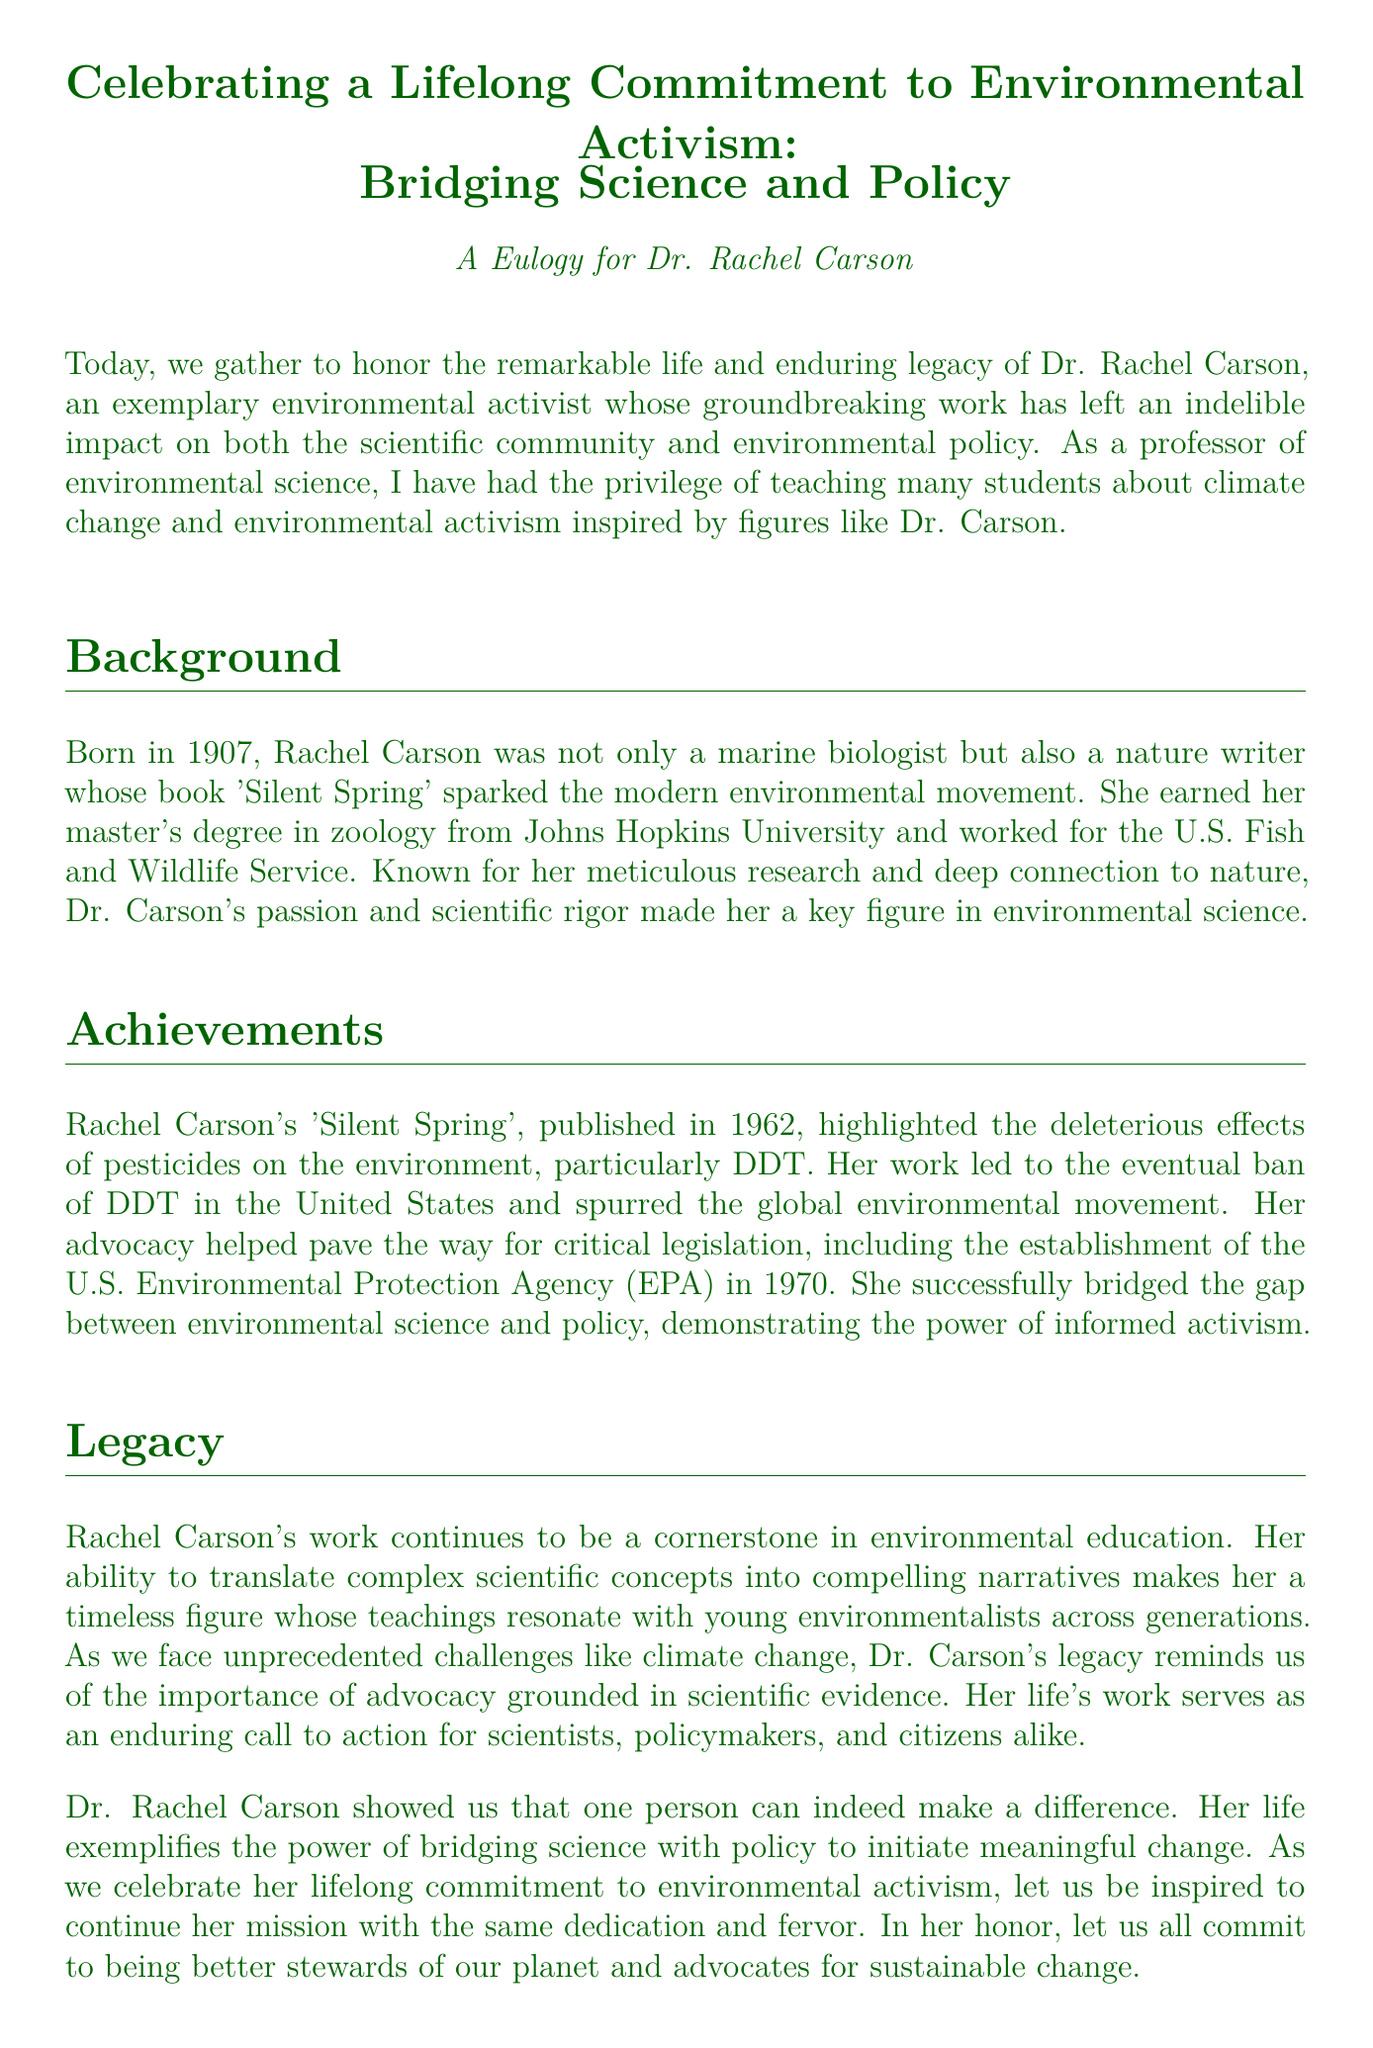What was the title of Rachel Carson's famous book? The document states that Rachel Carson is known for her book 'Silent Spring', which sparked the modern environmental movement.
Answer: 'Silent Spring' What year was 'Silent Spring' published? The document mentions that 'Silent Spring' was published in 1962, which is a significant milestone in Rachel Carson's activism.
Answer: 1962 What agency was established as a result of Carson's advocacy? The document states that her advocacy helped in the establishment of the U.S. Environmental Protection Agency (EPA) in 1970, showing her impact on environmental policy.
Answer: U.S. Environmental Protection Agency (EPA) How many years did Rachel Carson live? The document notes that Rachel Carson was born in 1907 and died in 1964, which can be calculated as 1964 - 1907.
Answer: 57 years What profession did Rachel Carson have aside from being an author? The document refers to Rachel Carson as a marine biologist, which highlights her scientific background.
Answer: marine biologist What periodical's work is highlighted for bridging science and policy? The document emphasizes that Rachel Carson’s 'Silent Spring' played a role in bridging the gap between environmental science and policy.
Answer: 'Silent Spring' What does the eulogy emphasize as a call to action? The eulogy states that Carson's life serves as an enduring call to action for scientists, policymakers, and citizens alike, encouraging proactive engagement.
Answer: enduring call to action What year was Rachel Carson born? The document specifies that Rachel Carson was born in 1907, marking the start of her lifelong commitment to environmental activism.
Answer: 1907 What type of writing is Rachel Carson known for? The document describes Dr. Carson as a nature writer, indicating her ability to communicate scientific concepts to a broader audience.
Answer: nature writer 